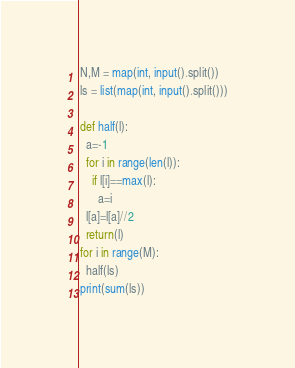Convert code to text. <code><loc_0><loc_0><loc_500><loc_500><_Python_>N,M = map(int, input().split())
ls = list(map(int, input().split()))

def half(l):
  a=-1
  for i in range(len(l)):
    if l[i]==max(l):
      a=i
  l[a]=l[a]//2
  return(l)
for i in range(M):
  half(ls)
print(sum(ls))</code> 